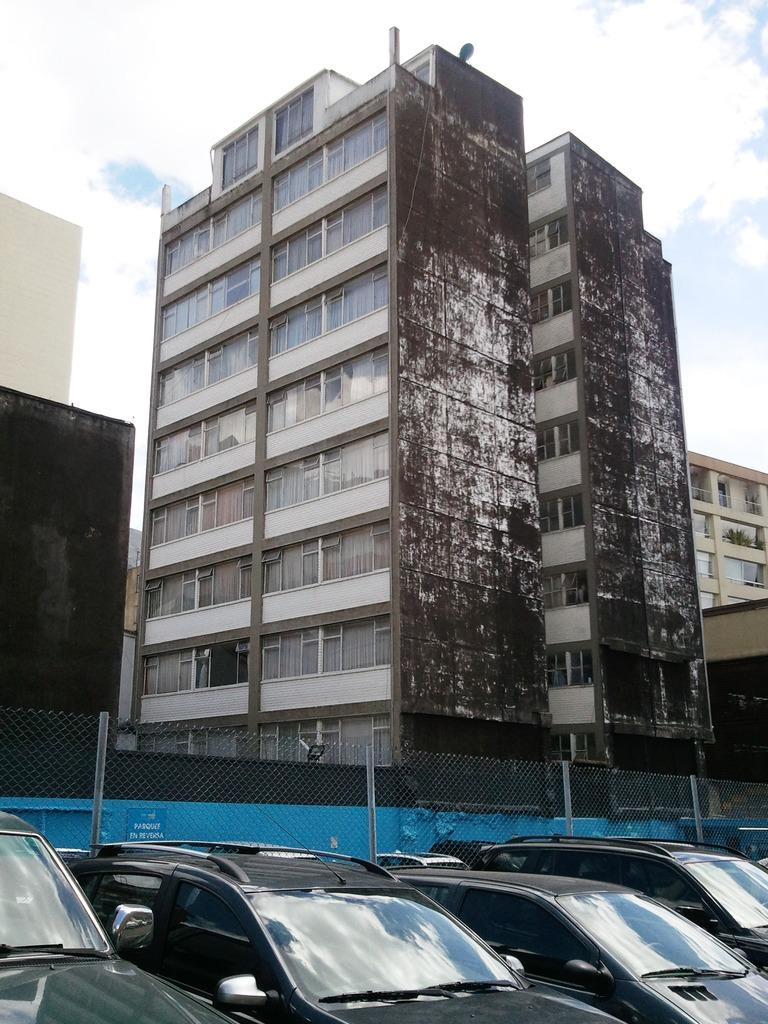What can be seen in the image? There are vehicles in the image. What is located next to the vehicles? There is a net fence next to the vehicles. What can be seen in the background of the image? There are buildings with windows and clouds visible in the background of the image. What else is visible in the background of the image? The sky is visible in the background of the image. What song is being played by the vehicles in the image? Vehicles do not play songs, so there is no song being played in the image. 